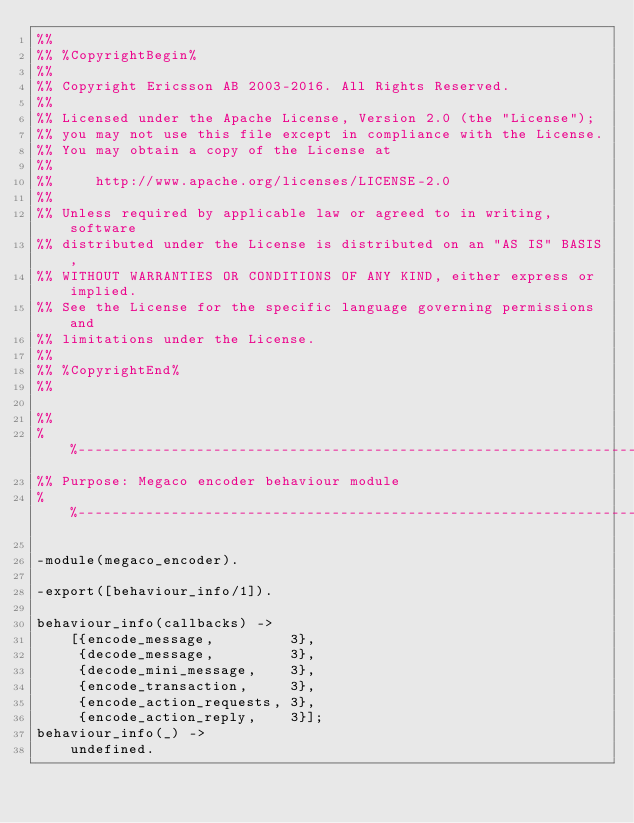<code> <loc_0><loc_0><loc_500><loc_500><_Erlang_>%%
%% %CopyrightBegin%
%% 
%% Copyright Ericsson AB 2003-2016. All Rights Reserved.
%% 
%% Licensed under the Apache License, Version 2.0 (the "License");
%% you may not use this file except in compliance with the License.
%% You may obtain a copy of the License at
%%
%%     http://www.apache.org/licenses/LICENSE-2.0
%%
%% Unless required by applicable law or agreed to in writing, software
%% distributed under the License is distributed on an "AS IS" BASIS,
%% WITHOUT WARRANTIES OR CONDITIONS OF ANY KIND, either express or implied.
%% See the License for the specific language governing permissions and
%% limitations under the License.
%% 
%% %CopyrightEnd%
%%

%%
%%----------------------------------------------------------------------
%% Purpose: Megaco encoder behaviour module
%%----------------------------------------------------------------------

-module(megaco_encoder).

-export([behaviour_info/1]).

behaviour_info(callbacks) ->
    [{encode_message,         3}, 
     {decode_message,         3},
     {decode_mini_message,    3},
     {encode_transaction,     3},
     {encode_action_requests, 3},
     {encode_action_reply,    3}];
behaviour_info(_) ->
    undefined.
</code> 